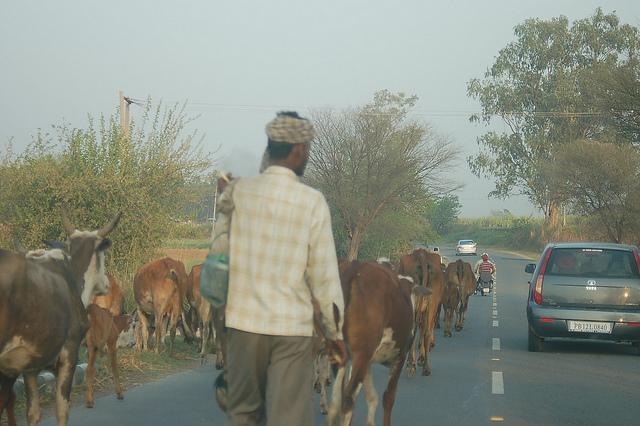How many cars in the picture?
Give a very brief answer. 2. How many people are there?
Give a very brief answer. 2. How many cows are there?
Give a very brief answer. 5. 